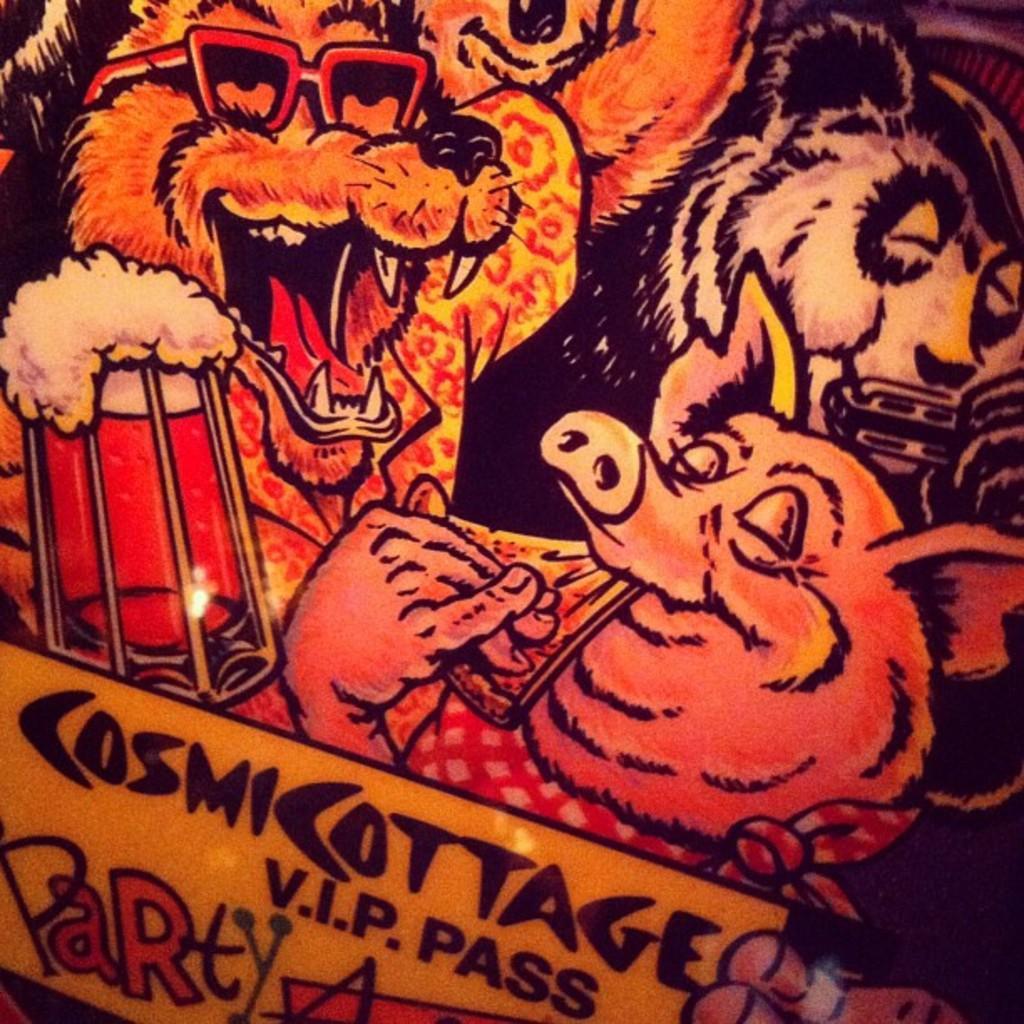Can you describe this image briefly? In this image there is a poster. In the poster we can see there are so many animals. At the bottom there is some text. 